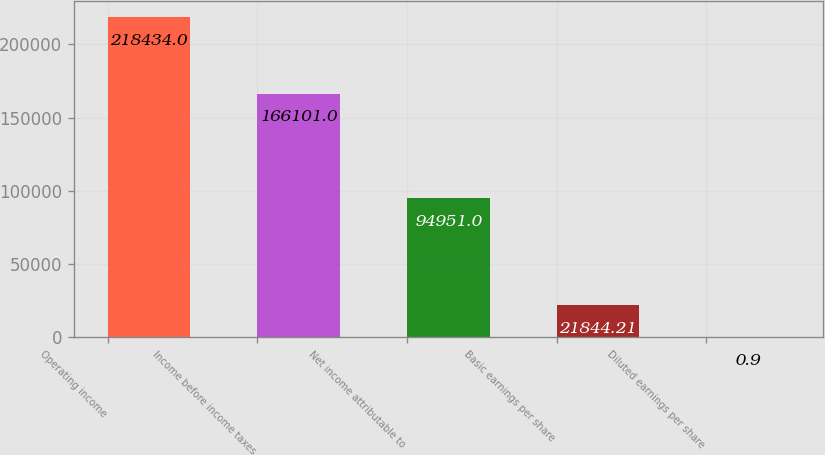Convert chart. <chart><loc_0><loc_0><loc_500><loc_500><bar_chart><fcel>Operating income<fcel>Income before income taxes<fcel>Net income attributable to<fcel>Basic earnings per share<fcel>Diluted earnings per share<nl><fcel>218434<fcel>166101<fcel>94951<fcel>21844.2<fcel>0.9<nl></chart> 